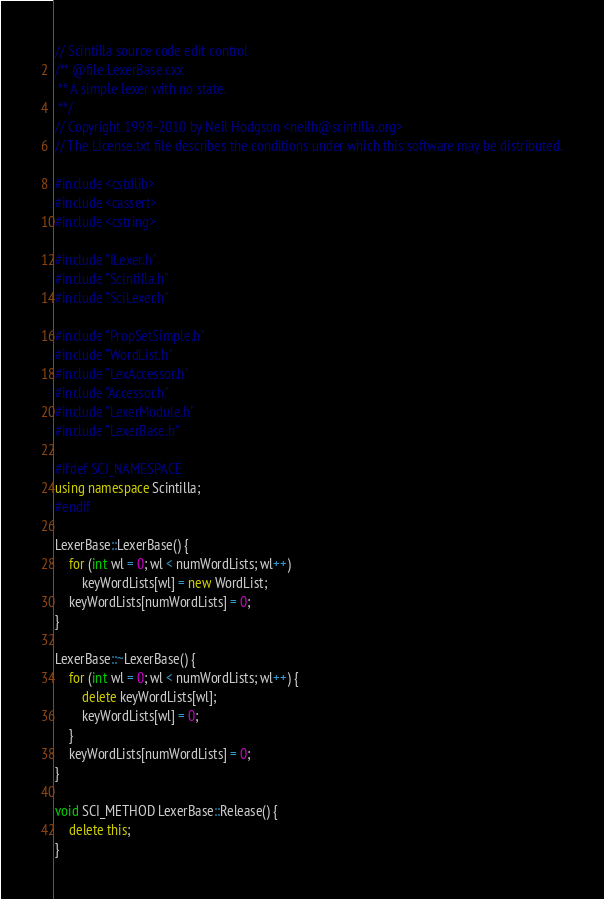Convert code to text. <code><loc_0><loc_0><loc_500><loc_500><_C++_>// Scintilla source code edit control
/** @file LexerBase.cxx
 ** A simple lexer with no state.
 **/
// Copyright 1998-2010 by Neil Hodgson <neilh@scintilla.org>
// The License.txt file describes the conditions under which this software may be distributed.

#include <cstdlib>
#include <cassert>
#include <cstring>

#include "ILexer.h"
#include "Scintilla.h"
#include "SciLexer.h"

#include "PropSetSimple.h"
#include "WordList.h"
#include "LexAccessor.h"
#include "Accessor.h"
#include "LexerModule.h"
#include "LexerBase.h"

#ifdef SCI_NAMESPACE
using namespace Scintilla;
#endif

LexerBase::LexerBase() {
	for (int wl = 0; wl < numWordLists; wl++)
		keyWordLists[wl] = new WordList;
	keyWordLists[numWordLists] = 0;
}

LexerBase::~LexerBase() {
	for (int wl = 0; wl < numWordLists; wl++) {
		delete keyWordLists[wl];
		keyWordLists[wl] = 0;
	}
	keyWordLists[numWordLists] = 0;
}

void SCI_METHOD LexerBase::Release() {
	delete this;
}
</code> 